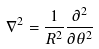<formula> <loc_0><loc_0><loc_500><loc_500>\nabla ^ { 2 } = \frac { 1 } { R ^ { 2 } } \frac { \partial ^ { 2 } } { \partial \theta ^ { 2 } }</formula> 